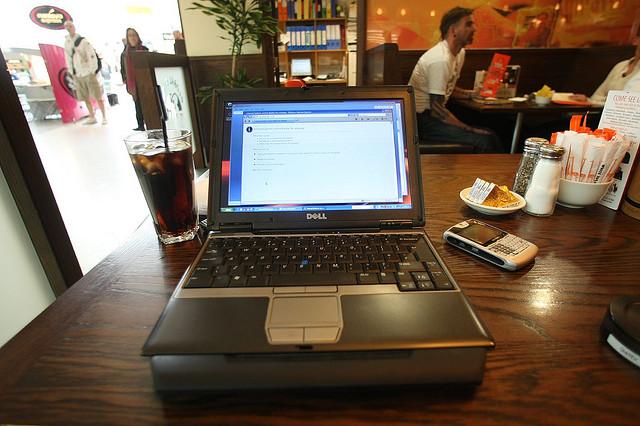Is the pepper full?
Quick response, please. Yes. What type of mobile phone is on the table?
Quick response, please. Blackberry. Has the seated man ordered?
Give a very brief answer. No. 